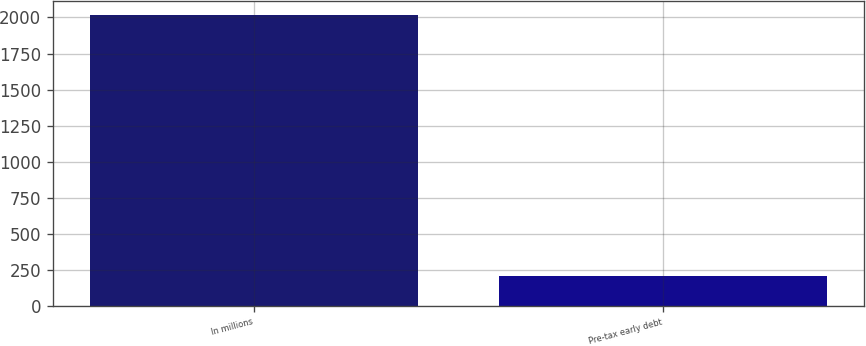Convert chart to OTSL. <chart><loc_0><loc_0><loc_500><loc_500><bar_chart><fcel>In millions<fcel>Pre-tax early debt<nl><fcel>2015<fcel>207<nl></chart> 